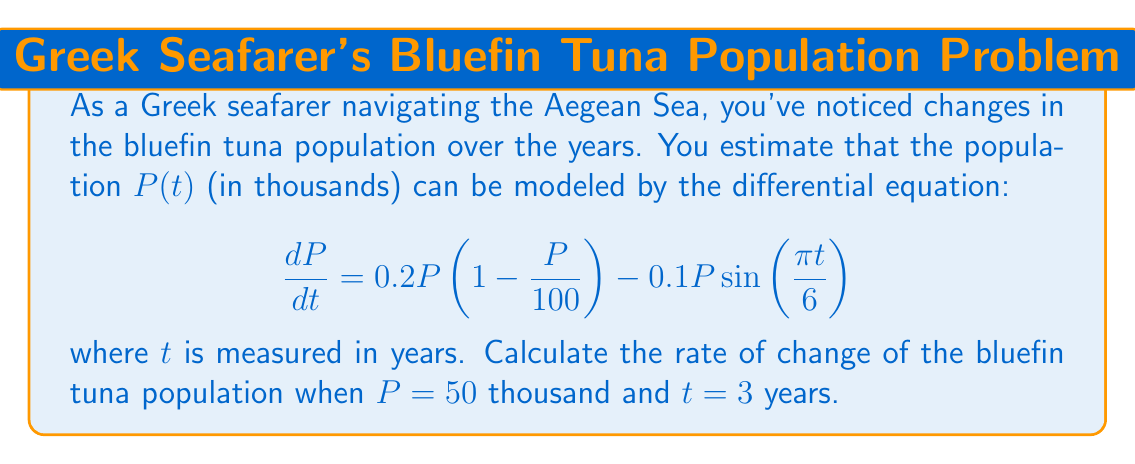Provide a solution to this math problem. Let's approach this step-by-step:

1) We are given the differential equation:
   $$\frac{dP}{dt} = 0.2P\left(1 - \frac{P}{100}\right) - 0.1P\sin\left(\frac{\pi t}{6}\right)$$

2) We need to find $\frac{dP}{dt}$ when $P = 50$ and $t = 3$.

3) Let's substitute these values into the equation:
   $$\frac{dP}{dt} = 0.2(50)\left(1 - \frac{50}{100}\right) - 0.1(50)\sin\left(\frac{\pi (3)}{6}\right)$$

4) Simplify the first term:
   $$0.2(50)\left(1 - \frac{50}{100}\right) = 0.2(50)(0.5) = 5$$

5) Simplify the second term:
   $$0.1(50)\sin\left(\frac{\pi (3)}{6}\right) = 5\sin\left(\frac{\pi}{2}\right) = 5$$

6) Now, we can combine these terms:
   $$\frac{dP}{dt} = 5 - 5 = 0$$

Therefore, when $P = 50$ thousand and $t = 3$ years, the rate of change of the bluefin tuna population is 0.
Answer: 0 thousand/year 